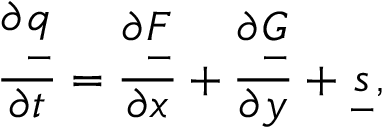<formula> <loc_0><loc_0><loc_500><loc_500>\frac { \partial \underset { - } { q } } { \partial t } = \frac { \partial \underset { - } { F } } { \partial x } + \frac { \partial \underset { - } { G } } { \partial y } + \underset { - } { s } ,</formula> 